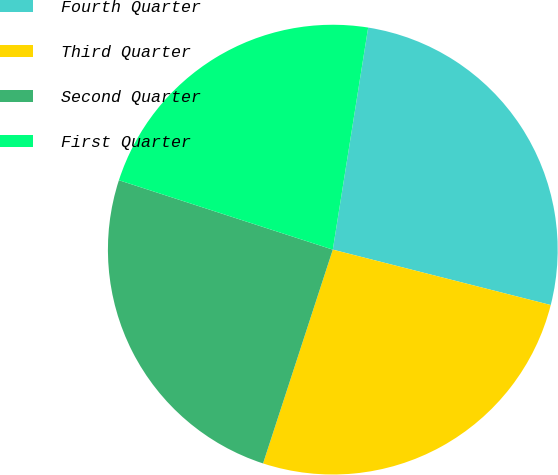Convert chart to OTSL. <chart><loc_0><loc_0><loc_500><loc_500><pie_chart><fcel>Fourth Quarter<fcel>Third Quarter<fcel>Second Quarter<fcel>First Quarter<nl><fcel>26.45%<fcel>26.06%<fcel>24.98%<fcel>22.52%<nl></chart> 